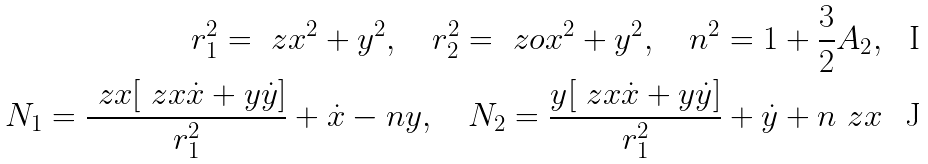<formula> <loc_0><loc_0><loc_500><loc_500>r ^ { 2 } _ { 1 } = \ z x ^ { 2 } + y ^ { 2 } , \quad r ^ { 2 } _ { 2 } = \ z o x ^ { 2 } + y ^ { 2 } , \quad n ^ { 2 } = 1 + \frac { 3 } { 2 } A _ { 2 } , \\ N _ { 1 } = \frac { \ z x [ \ z x \dot { x } + y \dot { y } ] } { r ^ { 2 } _ { 1 } } + \dot { x } - n y , \quad N _ { 2 } = \frac { y [ \ z x \dot { x } + y \dot { y } ] } { r ^ { 2 } _ { 1 } } + \dot { y } + n \ z x</formula> 